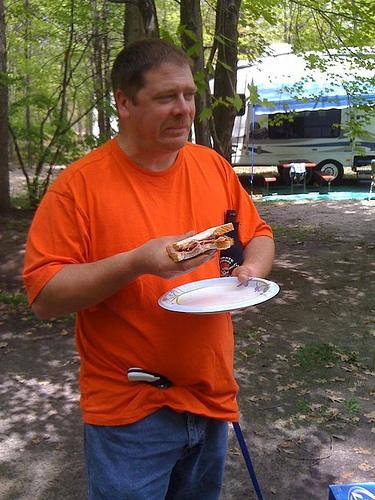What is the man in the image eating? The man is eating a meat and white bread sandwich. What specific type of item is the man holding in addition to the sandwich? The man is holding a white, round, flowered paper plate. Describe the table and the seating present in the image. There is a red picnic table with benches in the image. Where is the pistol located in the image? The pistol with a white handle grip is in the waistband of the man's pants. What type of canopy is present in the image? There is a blue roll-out awning in the image. What is the unique feature near the man's waist area? There is a white item, possibly a pistol, around the man's waist. What type of area are the man and the picnic table located in? They are in a field with brown and dead ground near the man, with trees and a camper in the woods. What type of beer container is present next to the man? There is a blue Bud Light box next to the man. What color is the man's shirt and what type of pants is he wearing? The man is wearing an orange shirt and blue jeans. Briefly describe the trees in the image. The trees in the image have green leaves and brown trunks. 